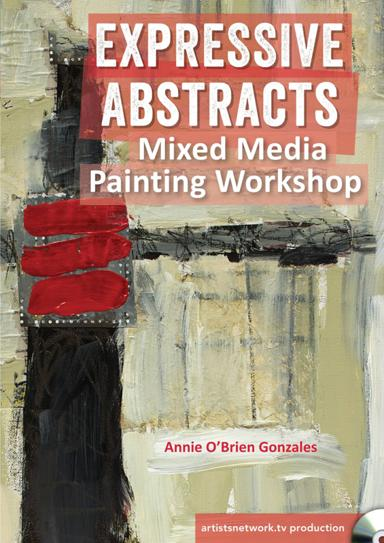What techniques might one learn in this 'Expressive Abstracts Mixed Media Painting Workshop'? In the Expressive Abstracts Mixed Media Painting Workshop, attendees can expect to explore various techniques such as layering, texturing, and combining different media to create dynamic and impactful abstract artworks. It's an excellent learning platform for artists interested in expanding their skill set in abstract art. 